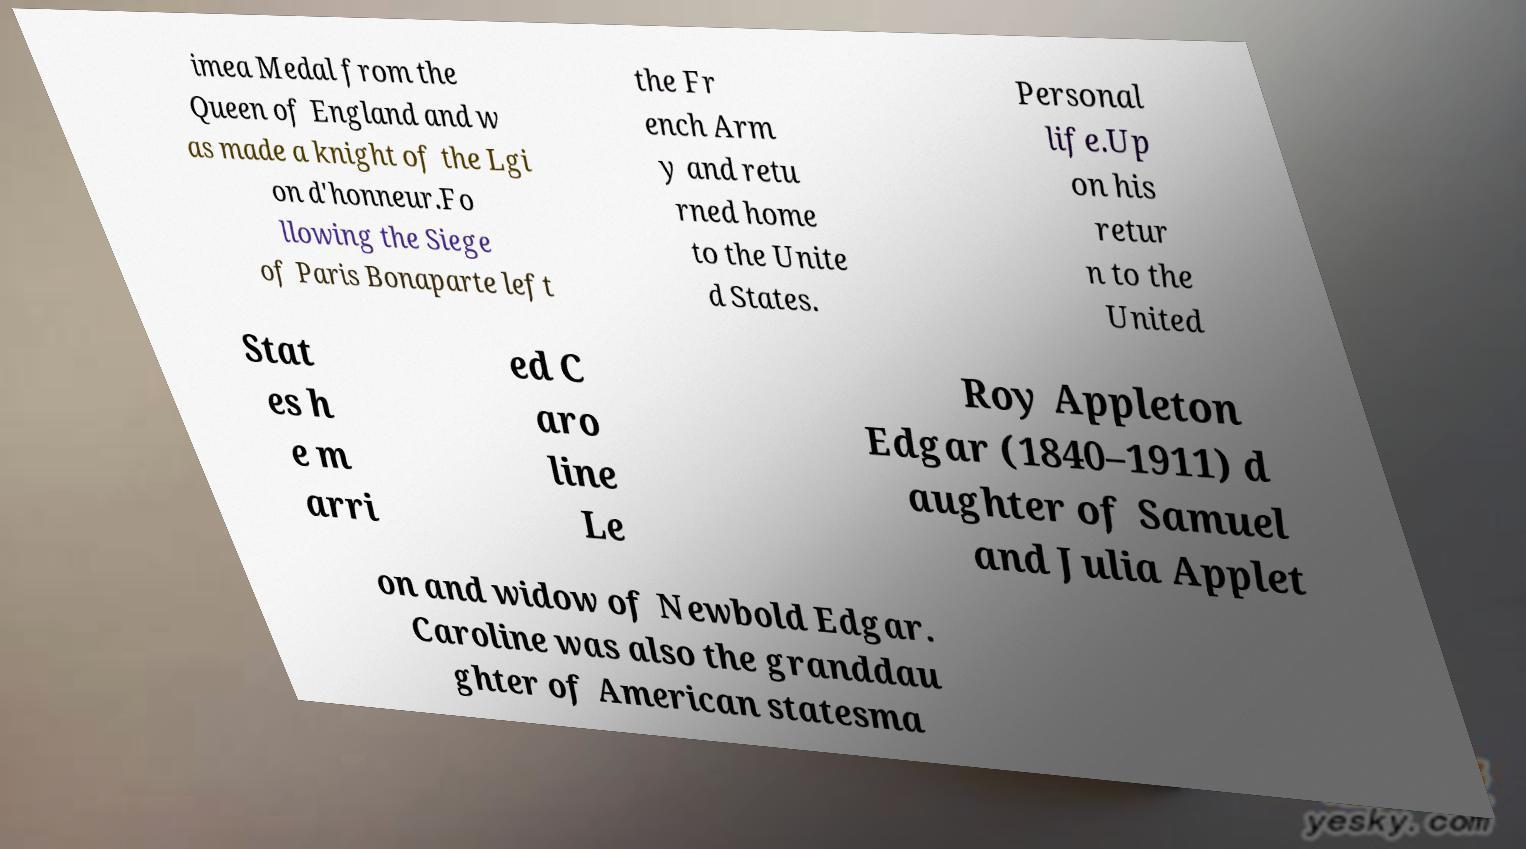Could you assist in decoding the text presented in this image and type it out clearly? imea Medal from the Queen of England and w as made a knight of the Lgi on d'honneur.Fo llowing the Siege of Paris Bonaparte left the Fr ench Arm y and retu rned home to the Unite d States. Personal life.Up on his retur n to the United Stat es h e m arri ed C aro line Le Roy Appleton Edgar (1840–1911) d aughter of Samuel and Julia Applet on and widow of Newbold Edgar. Caroline was also the granddau ghter of American statesma 